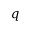<formula> <loc_0><loc_0><loc_500><loc_500>q</formula> 